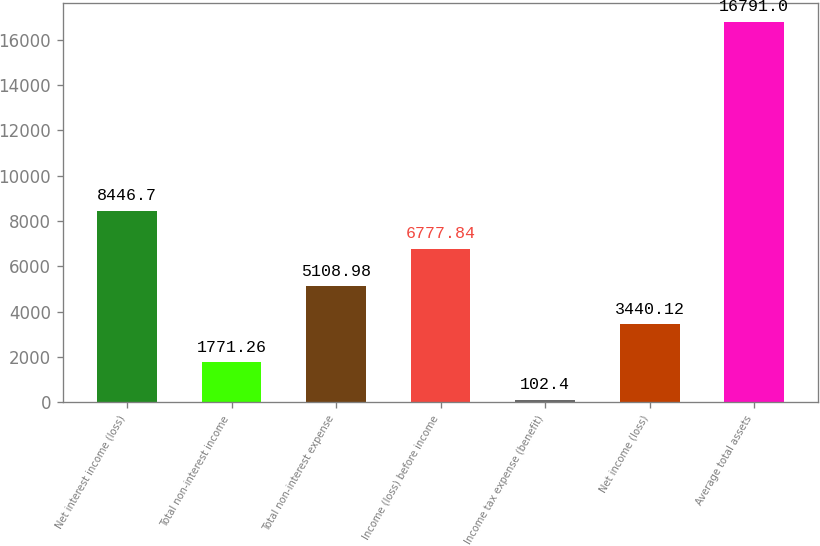<chart> <loc_0><loc_0><loc_500><loc_500><bar_chart><fcel>Net interest income (loss)<fcel>Total non-interest income<fcel>Total non-interest expense<fcel>Income (loss) before income<fcel>Income tax expense (benefit)<fcel>Net income (loss)<fcel>Average total assets<nl><fcel>8446.7<fcel>1771.26<fcel>5108.98<fcel>6777.84<fcel>102.4<fcel>3440.12<fcel>16791<nl></chart> 